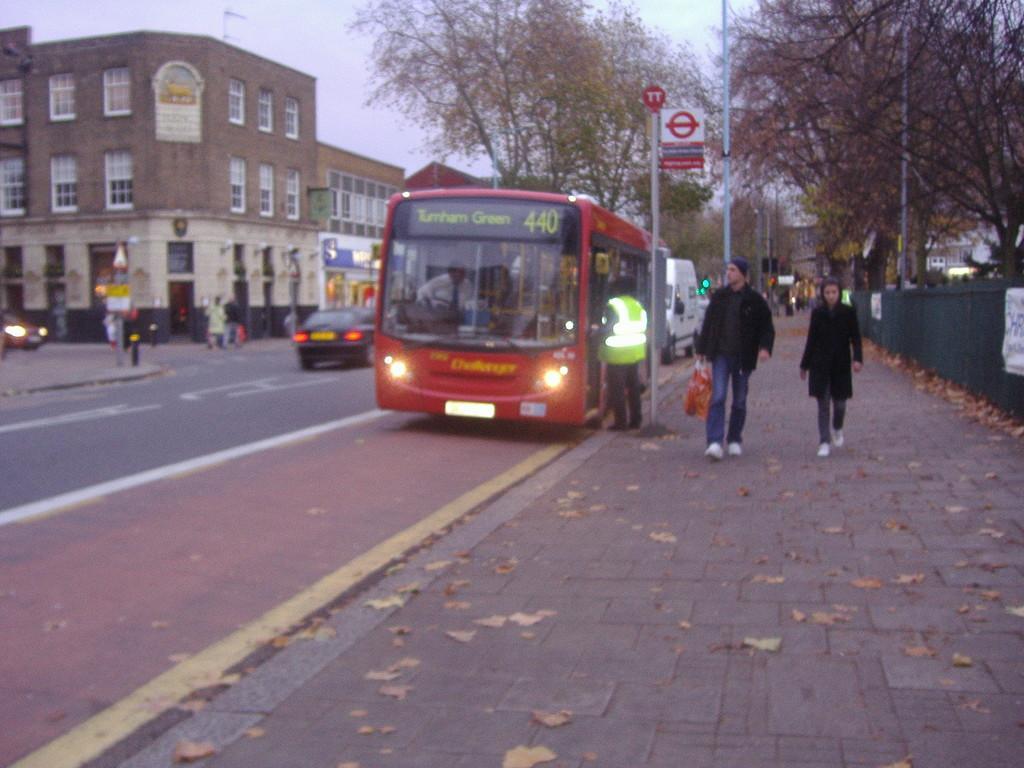Describe this image in one or two sentences. In this image there are vehicles on the road and we can see people. There are poles and boards. On the right there is a fence and we can see trees. There are buildings. In the background there is sky. 